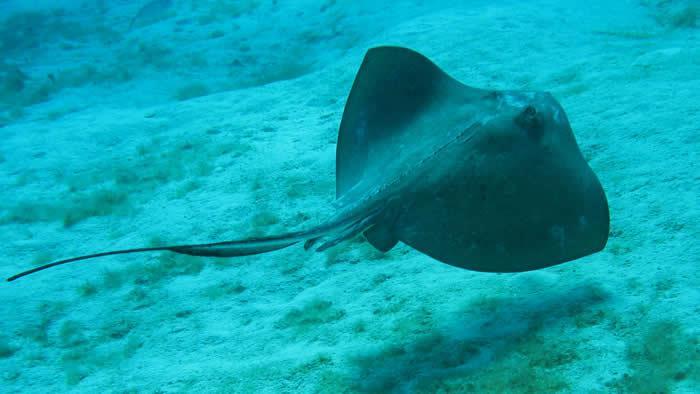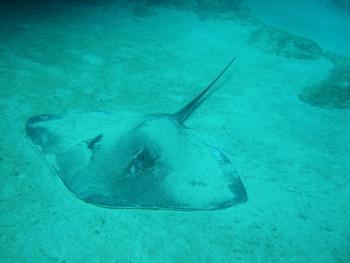The first image is the image on the left, the second image is the image on the right. Assess this claim about the two images: "Each image contains a single stingray, and the stingrays in the right and left images face opposite direction.". Correct or not? Answer yes or no. Yes. The first image is the image on the left, the second image is the image on the right. Given the left and right images, does the statement "The left image contains a sting ray that is swimming slightly upwards towards the right." hold true? Answer yes or no. Yes. 